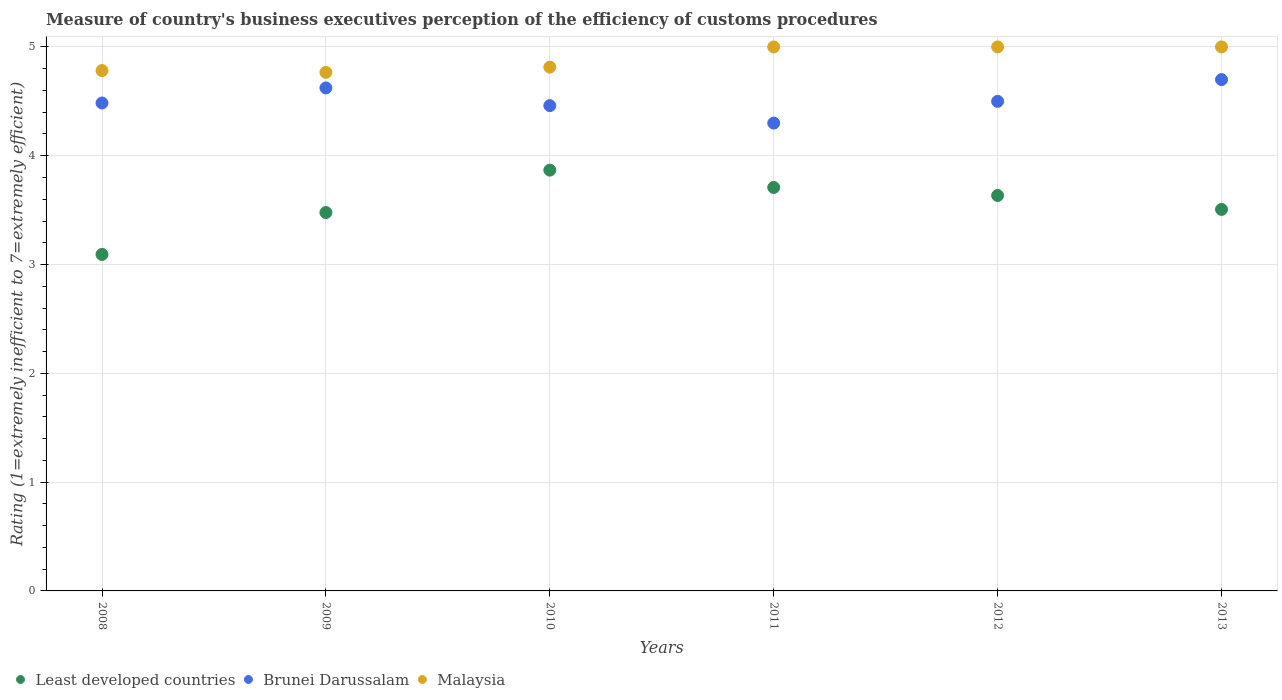What is the rating of the efficiency of customs procedure in Malaysia in 2012?
Your answer should be compact. 5. Across all years, what is the minimum rating of the efficiency of customs procedure in Least developed countries?
Keep it short and to the point. 3.09. What is the total rating of the efficiency of customs procedure in Least developed countries in the graph?
Provide a short and direct response. 21.29. What is the difference between the rating of the efficiency of customs procedure in Malaysia in 2008 and that in 2013?
Keep it short and to the point. -0.22. What is the difference between the rating of the efficiency of customs procedure in Least developed countries in 2013 and the rating of the efficiency of customs procedure in Brunei Darussalam in 2010?
Provide a succinct answer. -0.95. What is the average rating of the efficiency of customs procedure in Malaysia per year?
Your answer should be very brief. 4.89. In the year 2010, what is the difference between the rating of the efficiency of customs procedure in Brunei Darussalam and rating of the efficiency of customs procedure in Malaysia?
Your response must be concise. -0.35. What is the ratio of the rating of the efficiency of customs procedure in Malaysia in 2008 to that in 2010?
Provide a short and direct response. 0.99. What is the difference between the highest and the lowest rating of the efficiency of customs procedure in Malaysia?
Keep it short and to the point. 0.23. In how many years, is the rating of the efficiency of customs procedure in Least developed countries greater than the average rating of the efficiency of customs procedure in Least developed countries taken over all years?
Provide a short and direct response. 3. Is the sum of the rating of the efficiency of customs procedure in Least developed countries in 2009 and 2010 greater than the maximum rating of the efficiency of customs procedure in Malaysia across all years?
Provide a short and direct response. Yes. Is it the case that in every year, the sum of the rating of the efficiency of customs procedure in Brunei Darussalam and rating of the efficiency of customs procedure in Malaysia  is greater than the rating of the efficiency of customs procedure in Least developed countries?
Give a very brief answer. Yes. Is the rating of the efficiency of customs procedure in Malaysia strictly greater than the rating of the efficiency of customs procedure in Least developed countries over the years?
Your response must be concise. Yes. Is the rating of the efficiency of customs procedure in Least developed countries strictly less than the rating of the efficiency of customs procedure in Brunei Darussalam over the years?
Your answer should be compact. Yes. How many dotlines are there?
Keep it short and to the point. 3. Are the values on the major ticks of Y-axis written in scientific E-notation?
Ensure brevity in your answer.  No. Does the graph contain grids?
Give a very brief answer. Yes. What is the title of the graph?
Offer a terse response. Measure of country's business executives perception of the efficiency of customs procedures. Does "Spain" appear as one of the legend labels in the graph?
Ensure brevity in your answer.  No. What is the label or title of the X-axis?
Ensure brevity in your answer.  Years. What is the label or title of the Y-axis?
Your response must be concise. Rating (1=extremely inefficient to 7=extremely efficient). What is the Rating (1=extremely inefficient to 7=extremely efficient) of Least developed countries in 2008?
Keep it short and to the point. 3.09. What is the Rating (1=extremely inefficient to 7=extremely efficient) in Brunei Darussalam in 2008?
Your answer should be compact. 4.48. What is the Rating (1=extremely inefficient to 7=extremely efficient) of Malaysia in 2008?
Keep it short and to the point. 4.78. What is the Rating (1=extremely inefficient to 7=extremely efficient) in Least developed countries in 2009?
Provide a short and direct response. 3.48. What is the Rating (1=extremely inefficient to 7=extremely efficient) in Brunei Darussalam in 2009?
Your response must be concise. 4.62. What is the Rating (1=extremely inefficient to 7=extremely efficient) in Malaysia in 2009?
Keep it short and to the point. 4.77. What is the Rating (1=extremely inefficient to 7=extremely efficient) of Least developed countries in 2010?
Keep it short and to the point. 3.87. What is the Rating (1=extremely inefficient to 7=extremely efficient) in Brunei Darussalam in 2010?
Offer a very short reply. 4.46. What is the Rating (1=extremely inefficient to 7=extremely efficient) in Malaysia in 2010?
Give a very brief answer. 4.81. What is the Rating (1=extremely inefficient to 7=extremely efficient) in Least developed countries in 2011?
Give a very brief answer. 3.71. What is the Rating (1=extremely inefficient to 7=extremely efficient) of Malaysia in 2011?
Give a very brief answer. 5. What is the Rating (1=extremely inefficient to 7=extremely efficient) of Least developed countries in 2012?
Give a very brief answer. 3.63. What is the Rating (1=extremely inefficient to 7=extremely efficient) in Malaysia in 2012?
Make the answer very short. 5. What is the Rating (1=extremely inefficient to 7=extremely efficient) in Least developed countries in 2013?
Give a very brief answer. 3.51. Across all years, what is the maximum Rating (1=extremely inefficient to 7=extremely efficient) in Least developed countries?
Your answer should be very brief. 3.87. Across all years, what is the maximum Rating (1=extremely inefficient to 7=extremely efficient) in Malaysia?
Make the answer very short. 5. Across all years, what is the minimum Rating (1=extremely inefficient to 7=extremely efficient) of Least developed countries?
Ensure brevity in your answer.  3.09. Across all years, what is the minimum Rating (1=extremely inefficient to 7=extremely efficient) in Malaysia?
Offer a very short reply. 4.77. What is the total Rating (1=extremely inefficient to 7=extremely efficient) in Least developed countries in the graph?
Provide a short and direct response. 21.29. What is the total Rating (1=extremely inefficient to 7=extremely efficient) of Brunei Darussalam in the graph?
Offer a terse response. 27.07. What is the total Rating (1=extremely inefficient to 7=extremely efficient) of Malaysia in the graph?
Keep it short and to the point. 29.36. What is the difference between the Rating (1=extremely inefficient to 7=extremely efficient) of Least developed countries in 2008 and that in 2009?
Offer a terse response. -0.39. What is the difference between the Rating (1=extremely inefficient to 7=extremely efficient) in Brunei Darussalam in 2008 and that in 2009?
Provide a short and direct response. -0.14. What is the difference between the Rating (1=extremely inefficient to 7=extremely efficient) of Malaysia in 2008 and that in 2009?
Make the answer very short. 0.02. What is the difference between the Rating (1=extremely inefficient to 7=extremely efficient) of Least developed countries in 2008 and that in 2010?
Offer a terse response. -0.77. What is the difference between the Rating (1=extremely inefficient to 7=extremely efficient) of Brunei Darussalam in 2008 and that in 2010?
Offer a terse response. 0.02. What is the difference between the Rating (1=extremely inefficient to 7=extremely efficient) of Malaysia in 2008 and that in 2010?
Your answer should be very brief. -0.03. What is the difference between the Rating (1=extremely inefficient to 7=extremely efficient) of Least developed countries in 2008 and that in 2011?
Make the answer very short. -0.62. What is the difference between the Rating (1=extremely inefficient to 7=extremely efficient) of Brunei Darussalam in 2008 and that in 2011?
Give a very brief answer. 0.18. What is the difference between the Rating (1=extremely inefficient to 7=extremely efficient) of Malaysia in 2008 and that in 2011?
Offer a very short reply. -0.22. What is the difference between the Rating (1=extremely inefficient to 7=extremely efficient) of Least developed countries in 2008 and that in 2012?
Provide a succinct answer. -0.54. What is the difference between the Rating (1=extremely inefficient to 7=extremely efficient) in Brunei Darussalam in 2008 and that in 2012?
Ensure brevity in your answer.  -0.02. What is the difference between the Rating (1=extremely inefficient to 7=extremely efficient) of Malaysia in 2008 and that in 2012?
Your answer should be compact. -0.22. What is the difference between the Rating (1=extremely inefficient to 7=extremely efficient) of Least developed countries in 2008 and that in 2013?
Offer a very short reply. -0.41. What is the difference between the Rating (1=extremely inefficient to 7=extremely efficient) in Brunei Darussalam in 2008 and that in 2013?
Make the answer very short. -0.22. What is the difference between the Rating (1=extremely inefficient to 7=extremely efficient) in Malaysia in 2008 and that in 2013?
Your response must be concise. -0.22. What is the difference between the Rating (1=extremely inefficient to 7=extremely efficient) in Least developed countries in 2009 and that in 2010?
Keep it short and to the point. -0.39. What is the difference between the Rating (1=extremely inefficient to 7=extremely efficient) of Brunei Darussalam in 2009 and that in 2010?
Provide a succinct answer. 0.16. What is the difference between the Rating (1=extremely inefficient to 7=extremely efficient) in Malaysia in 2009 and that in 2010?
Your answer should be compact. -0.05. What is the difference between the Rating (1=extremely inefficient to 7=extremely efficient) in Least developed countries in 2009 and that in 2011?
Your answer should be very brief. -0.23. What is the difference between the Rating (1=extremely inefficient to 7=extremely efficient) in Brunei Darussalam in 2009 and that in 2011?
Give a very brief answer. 0.32. What is the difference between the Rating (1=extremely inefficient to 7=extremely efficient) in Malaysia in 2009 and that in 2011?
Make the answer very short. -0.23. What is the difference between the Rating (1=extremely inefficient to 7=extremely efficient) of Least developed countries in 2009 and that in 2012?
Make the answer very short. -0.16. What is the difference between the Rating (1=extremely inefficient to 7=extremely efficient) in Brunei Darussalam in 2009 and that in 2012?
Your answer should be very brief. 0.12. What is the difference between the Rating (1=extremely inefficient to 7=extremely efficient) of Malaysia in 2009 and that in 2012?
Provide a succinct answer. -0.23. What is the difference between the Rating (1=extremely inefficient to 7=extremely efficient) in Least developed countries in 2009 and that in 2013?
Ensure brevity in your answer.  -0.03. What is the difference between the Rating (1=extremely inefficient to 7=extremely efficient) of Brunei Darussalam in 2009 and that in 2013?
Provide a succinct answer. -0.08. What is the difference between the Rating (1=extremely inefficient to 7=extremely efficient) of Malaysia in 2009 and that in 2013?
Provide a succinct answer. -0.23. What is the difference between the Rating (1=extremely inefficient to 7=extremely efficient) of Least developed countries in 2010 and that in 2011?
Keep it short and to the point. 0.16. What is the difference between the Rating (1=extremely inefficient to 7=extremely efficient) in Brunei Darussalam in 2010 and that in 2011?
Provide a succinct answer. 0.16. What is the difference between the Rating (1=extremely inefficient to 7=extremely efficient) in Malaysia in 2010 and that in 2011?
Your answer should be very brief. -0.19. What is the difference between the Rating (1=extremely inefficient to 7=extremely efficient) of Least developed countries in 2010 and that in 2012?
Ensure brevity in your answer.  0.23. What is the difference between the Rating (1=extremely inefficient to 7=extremely efficient) of Brunei Darussalam in 2010 and that in 2012?
Your response must be concise. -0.04. What is the difference between the Rating (1=extremely inefficient to 7=extremely efficient) in Malaysia in 2010 and that in 2012?
Ensure brevity in your answer.  -0.19. What is the difference between the Rating (1=extremely inefficient to 7=extremely efficient) of Least developed countries in 2010 and that in 2013?
Offer a terse response. 0.36. What is the difference between the Rating (1=extremely inefficient to 7=extremely efficient) of Brunei Darussalam in 2010 and that in 2013?
Your answer should be very brief. -0.24. What is the difference between the Rating (1=extremely inefficient to 7=extremely efficient) of Malaysia in 2010 and that in 2013?
Ensure brevity in your answer.  -0.19. What is the difference between the Rating (1=extremely inefficient to 7=extremely efficient) in Least developed countries in 2011 and that in 2012?
Keep it short and to the point. 0.07. What is the difference between the Rating (1=extremely inefficient to 7=extremely efficient) of Malaysia in 2011 and that in 2012?
Your answer should be very brief. 0. What is the difference between the Rating (1=extremely inefficient to 7=extremely efficient) of Least developed countries in 2011 and that in 2013?
Offer a terse response. 0.2. What is the difference between the Rating (1=extremely inefficient to 7=extremely efficient) of Brunei Darussalam in 2011 and that in 2013?
Offer a very short reply. -0.4. What is the difference between the Rating (1=extremely inefficient to 7=extremely efficient) in Least developed countries in 2012 and that in 2013?
Make the answer very short. 0.13. What is the difference between the Rating (1=extremely inefficient to 7=extremely efficient) in Malaysia in 2012 and that in 2013?
Offer a very short reply. 0. What is the difference between the Rating (1=extremely inefficient to 7=extremely efficient) in Least developed countries in 2008 and the Rating (1=extremely inefficient to 7=extremely efficient) in Brunei Darussalam in 2009?
Offer a very short reply. -1.53. What is the difference between the Rating (1=extremely inefficient to 7=extremely efficient) of Least developed countries in 2008 and the Rating (1=extremely inefficient to 7=extremely efficient) of Malaysia in 2009?
Keep it short and to the point. -1.67. What is the difference between the Rating (1=extremely inefficient to 7=extremely efficient) in Brunei Darussalam in 2008 and the Rating (1=extremely inefficient to 7=extremely efficient) in Malaysia in 2009?
Offer a terse response. -0.28. What is the difference between the Rating (1=extremely inefficient to 7=extremely efficient) of Least developed countries in 2008 and the Rating (1=extremely inefficient to 7=extremely efficient) of Brunei Darussalam in 2010?
Ensure brevity in your answer.  -1.37. What is the difference between the Rating (1=extremely inefficient to 7=extremely efficient) in Least developed countries in 2008 and the Rating (1=extremely inefficient to 7=extremely efficient) in Malaysia in 2010?
Provide a succinct answer. -1.72. What is the difference between the Rating (1=extremely inefficient to 7=extremely efficient) of Brunei Darussalam in 2008 and the Rating (1=extremely inefficient to 7=extremely efficient) of Malaysia in 2010?
Provide a short and direct response. -0.33. What is the difference between the Rating (1=extremely inefficient to 7=extremely efficient) in Least developed countries in 2008 and the Rating (1=extremely inefficient to 7=extremely efficient) in Brunei Darussalam in 2011?
Keep it short and to the point. -1.21. What is the difference between the Rating (1=extremely inefficient to 7=extremely efficient) of Least developed countries in 2008 and the Rating (1=extremely inefficient to 7=extremely efficient) of Malaysia in 2011?
Offer a terse response. -1.91. What is the difference between the Rating (1=extremely inefficient to 7=extremely efficient) in Brunei Darussalam in 2008 and the Rating (1=extremely inefficient to 7=extremely efficient) in Malaysia in 2011?
Offer a terse response. -0.52. What is the difference between the Rating (1=extremely inefficient to 7=extremely efficient) of Least developed countries in 2008 and the Rating (1=extremely inefficient to 7=extremely efficient) of Brunei Darussalam in 2012?
Your answer should be very brief. -1.41. What is the difference between the Rating (1=extremely inefficient to 7=extremely efficient) in Least developed countries in 2008 and the Rating (1=extremely inefficient to 7=extremely efficient) in Malaysia in 2012?
Keep it short and to the point. -1.91. What is the difference between the Rating (1=extremely inefficient to 7=extremely efficient) in Brunei Darussalam in 2008 and the Rating (1=extremely inefficient to 7=extremely efficient) in Malaysia in 2012?
Your answer should be compact. -0.52. What is the difference between the Rating (1=extremely inefficient to 7=extremely efficient) in Least developed countries in 2008 and the Rating (1=extremely inefficient to 7=extremely efficient) in Brunei Darussalam in 2013?
Offer a very short reply. -1.61. What is the difference between the Rating (1=extremely inefficient to 7=extremely efficient) of Least developed countries in 2008 and the Rating (1=extremely inefficient to 7=extremely efficient) of Malaysia in 2013?
Your response must be concise. -1.91. What is the difference between the Rating (1=extremely inefficient to 7=extremely efficient) of Brunei Darussalam in 2008 and the Rating (1=extremely inefficient to 7=extremely efficient) of Malaysia in 2013?
Your answer should be compact. -0.52. What is the difference between the Rating (1=extremely inefficient to 7=extremely efficient) of Least developed countries in 2009 and the Rating (1=extremely inefficient to 7=extremely efficient) of Brunei Darussalam in 2010?
Your response must be concise. -0.98. What is the difference between the Rating (1=extremely inefficient to 7=extremely efficient) of Least developed countries in 2009 and the Rating (1=extremely inefficient to 7=extremely efficient) of Malaysia in 2010?
Your answer should be compact. -1.34. What is the difference between the Rating (1=extremely inefficient to 7=extremely efficient) in Brunei Darussalam in 2009 and the Rating (1=extremely inefficient to 7=extremely efficient) in Malaysia in 2010?
Provide a short and direct response. -0.19. What is the difference between the Rating (1=extremely inefficient to 7=extremely efficient) in Least developed countries in 2009 and the Rating (1=extremely inefficient to 7=extremely efficient) in Brunei Darussalam in 2011?
Ensure brevity in your answer.  -0.82. What is the difference between the Rating (1=extremely inefficient to 7=extremely efficient) of Least developed countries in 2009 and the Rating (1=extremely inefficient to 7=extremely efficient) of Malaysia in 2011?
Provide a succinct answer. -1.52. What is the difference between the Rating (1=extremely inefficient to 7=extremely efficient) of Brunei Darussalam in 2009 and the Rating (1=extremely inefficient to 7=extremely efficient) of Malaysia in 2011?
Give a very brief answer. -0.38. What is the difference between the Rating (1=extremely inefficient to 7=extremely efficient) of Least developed countries in 2009 and the Rating (1=extremely inefficient to 7=extremely efficient) of Brunei Darussalam in 2012?
Ensure brevity in your answer.  -1.02. What is the difference between the Rating (1=extremely inefficient to 7=extremely efficient) in Least developed countries in 2009 and the Rating (1=extremely inefficient to 7=extremely efficient) in Malaysia in 2012?
Keep it short and to the point. -1.52. What is the difference between the Rating (1=extremely inefficient to 7=extremely efficient) in Brunei Darussalam in 2009 and the Rating (1=extremely inefficient to 7=extremely efficient) in Malaysia in 2012?
Your answer should be compact. -0.38. What is the difference between the Rating (1=extremely inefficient to 7=extremely efficient) of Least developed countries in 2009 and the Rating (1=extremely inefficient to 7=extremely efficient) of Brunei Darussalam in 2013?
Offer a very short reply. -1.22. What is the difference between the Rating (1=extremely inefficient to 7=extremely efficient) of Least developed countries in 2009 and the Rating (1=extremely inefficient to 7=extremely efficient) of Malaysia in 2013?
Give a very brief answer. -1.52. What is the difference between the Rating (1=extremely inefficient to 7=extremely efficient) of Brunei Darussalam in 2009 and the Rating (1=extremely inefficient to 7=extremely efficient) of Malaysia in 2013?
Make the answer very short. -0.38. What is the difference between the Rating (1=extremely inefficient to 7=extremely efficient) in Least developed countries in 2010 and the Rating (1=extremely inefficient to 7=extremely efficient) in Brunei Darussalam in 2011?
Offer a terse response. -0.43. What is the difference between the Rating (1=extremely inefficient to 7=extremely efficient) of Least developed countries in 2010 and the Rating (1=extremely inefficient to 7=extremely efficient) of Malaysia in 2011?
Offer a very short reply. -1.13. What is the difference between the Rating (1=extremely inefficient to 7=extremely efficient) of Brunei Darussalam in 2010 and the Rating (1=extremely inefficient to 7=extremely efficient) of Malaysia in 2011?
Your response must be concise. -0.54. What is the difference between the Rating (1=extremely inefficient to 7=extremely efficient) in Least developed countries in 2010 and the Rating (1=extremely inefficient to 7=extremely efficient) in Brunei Darussalam in 2012?
Your answer should be compact. -0.63. What is the difference between the Rating (1=extremely inefficient to 7=extremely efficient) of Least developed countries in 2010 and the Rating (1=extremely inefficient to 7=extremely efficient) of Malaysia in 2012?
Give a very brief answer. -1.13. What is the difference between the Rating (1=extremely inefficient to 7=extremely efficient) in Brunei Darussalam in 2010 and the Rating (1=extremely inefficient to 7=extremely efficient) in Malaysia in 2012?
Your response must be concise. -0.54. What is the difference between the Rating (1=extremely inefficient to 7=extremely efficient) in Least developed countries in 2010 and the Rating (1=extremely inefficient to 7=extremely efficient) in Brunei Darussalam in 2013?
Provide a succinct answer. -0.83. What is the difference between the Rating (1=extremely inefficient to 7=extremely efficient) of Least developed countries in 2010 and the Rating (1=extremely inefficient to 7=extremely efficient) of Malaysia in 2013?
Make the answer very short. -1.13. What is the difference between the Rating (1=extremely inefficient to 7=extremely efficient) of Brunei Darussalam in 2010 and the Rating (1=extremely inefficient to 7=extremely efficient) of Malaysia in 2013?
Make the answer very short. -0.54. What is the difference between the Rating (1=extremely inefficient to 7=extremely efficient) in Least developed countries in 2011 and the Rating (1=extremely inefficient to 7=extremely efficient) in Brunei Darussalam in 2012?
Your response must be concise. -0.79. What is the difference between the Rating (1=extremely inefficient to 7=extremely efficient) of Least developed countries in 2011 and the Rating (1=extremely inefficient to 7=extremely efficient) of Malaysia in 2012?
Provide a succinct answer. -1.29. What is the difference between the Rating (1=extremely inefficient to 7=extremely efficient) in Brunei Darussalam in 2011 and the Rating (1=extremely inefficient to 7=extremely efficient) in Malaysia in 2012?
Keep it short and to the point. -0.7. What is the difference between the Rating (1=extremely inefficient to 7=extremely efficient) of Least developed countries in 2011 and the Rating (1=extremely inefficient to 7=extremely efficient) of Brunei Darussalam in 2013?
Your answer should be compact. -0.99. What is the difference between the Rating (1=extremely inefficient to 7=extremely efficient) of Least developed countries in 2011 and the Rating (1=extremely inefficient to 7=extremely efficient) of Malaysia in 2013?
Give a very brief answer. -1.29. What is the difference between the Rating (1=extremely inefficient to 7=extremely efficient) of Least developed countries in 2012 and the Rating (1=extremely inefficient to 7=extremely efficient) of Brunei Darussalam in 2013?
Keep it short and to the point. -1.07. What is the difference between the Rating (1=extremely inefficient to 7=extremely efficient) in Least developed countries in 2012 and the Rating (1=extremely inefficient to 7=extremely efficient) in Malaysia in 2013?
Provide a short and direct response. -1.37. What is the average Rating (1=extremely inefficient to 7=extremely efficient) in Least developed countries per year?
Make the answer very short. 3.55. What is the average Rating (1=extremely inefficient to 7=extremely efficient) in Brunei Darussalam per year?
Provide a short and direct response. 4.51. What is the average Rating (1=extremely inefficient to 7=extremely efficient) in Malaysia per year?
Give a very brief answer. 4.89. In the year 2008, what is the difference between the Rating (1=extremely inefficient to 7=extremely efficient) of Least developed countries and Rating (1=extremely inefficient to 7=extremely efficient) of Brunei Darussalam?
Offer a terse response. -1.39. In the year 2008, what is the difference between the Rating (1=extremely inefficient to 7=extremely efficient) of Least developed countries and Rating (1=extremely inefficient to 7=extremely efficient) of Malaysia?
Offer a terse response. -1.69. In the year 2008, what is the difference between the Rating (1=extremely inefficient to 7=extremely efficient) in Brunei Darussalam and Rating (1=extremely inefficient to 7=extremely efficient) in Malaysia?
Your answer should be very brief. -0.3. In the year 2009, what is the difference between the Rating (1=extremely inefficient to 7=extremely efficient) in Least developed countries and Rating (1=extremely inefficient to 7=extremely efficient) in Brunei Darussalam?
Offer a very short reply. -1.15. In the year 2009, what is the difference between the Rating (1=extremely inefficient to 7=extremely efficient) of Least developed countries and Rating (1=extremely inefficient to 7=extremely efficient) of Malaysia?
Provide a short and direct response. -1.29. In the year 2009, what is the difference between the Rating (1=extremely inefficient to 7=extremely efficient) in Brunei Darussalam and Rating (1=extremely inefficient to 7=extremely efficient) in Malaysia?
Offer a terse response. -0.14. In the year 2010, what is the difference between the Rating (1=extremely inefficient to 7=extremely efficient) in Least developed countries and Rating (1=extremely inefficient to 7=extremely efficient) in Brunei Darussalam?
Your answer should be compact. -0.59. In the year 2010, what is the difference between the Rating (1=extremely inefficient to 7=extremely efficient) in Least developed countries and Rating (1=extremely inefficient to 7=extremely efficient) in Malaysia?
Your answer should be very brief. -0.95. In the year 2010, what is the difference between the Rating (1=extremely inefficient to 7=extremely efficient) of Brunei Darussalam and Rating (1=extremely inefficient to 7=extremely efficient) of Malaysia?
Make the answer very short. -0.35. In the year 2011, what is the difference between the Rating (1=extremely inefficient to 7=extremely efficient) of Least developed countries and Rating (1=extremely inefficient to 7=extremely efficient) of Brunei Darussalam?
Provide a short and direct response. -0.59. In the year 2011, what is the difference between the Rating (1=extremely inefficient to 7=extremely efficient) in Least developed countries and Rating (1=extremely inefficient to 7=extremely efficient) in Malaysia?
Your answer should be very brief. -1.29. In the year 2011, what is the difference between the Rating (1=extremely inefficient to 7=extremely efficient) in Brunei Darussalam and Rating (1=extremely inefficient to 7=extremely efficient) in Malaysia?
Provide a succinct answer. -0.7. In the year 2012, what is the difference between the Rating (1=extremely inefficient to 7=extremely efficient) of Least developed countries and Rating (1=extremely inefficient to 7=extremely efficient) of Brunei Darussalam?
Your answer should be compact. -0.87. In the year 2012, what is the difference between the Rating (1=extremely inefficient to 7=extremely efficient) of Least developed countries and Rating (1=extremely inefficient to 7=extremely efficient) of Malaysia?
Your answer should be compact. -1.37. In the year 2012, what is the difference between the Rating (1=extremely inefficient to 7=extremely efficient) of Brunei Darussalam and Rating (1=extremely inefficient to 7=extremely efficient) of Malaysia?
Provide a succinct answer. -0.5. In the year 2013, what is the difference between the Rating (1=extremely inefficient to 7=extremely efficient) in Least developed countries and Rating (1=extremely inefficient to 7=extremely efficient) in Brunei Darussalam?
Offer a terse response. -1.19. In the year 2013, what is the difference between the Rating (1=extremely inefficient to 7=extremely efficient) of Least developed countries and Rating (1=extremely inefficient to 7=extremely efficient) of Malaysia?
Your answer should be very brief. -1.49. In the year 2013, what is the difference between the Rating (1=extremely inefficient to 7=extremely efficient) of Brunei Darussalam and Rating (1=extremely inefficient to 7=extremely efficient) of Malaysia?
Provide a short and direct response. -0.3. What is the ratio of the Rating (1=extremely inefficient to 7=extremely efficient) of Least developed countries in 2008 to that in 2009?
Make the answer very short. 0.89. What is the ratio of the Rating (1=extremely inefficient to 7=extremely efficient) in Brunei Darussalam in 2008 to that in 2009?
Your response must be concise. 0.97. What is the ratio of the Rating (1=extremely inefficient to 7=extremely efficient) in Least developed countries in 2008 to that in 2010?
Make the answer very short. 0.8. What is the ratio of the Rating (1=extremely inefficient to 7=extremely efficient) in Brunei Darussalam in 2008 to that in 2010?
Your answer should be very brief. 1.01. What is the ratio of the Rating (1=extremely inefficient to 7=extremely efficient) of Malaysia in 2008 to that in 2010?
Ensure brevity in your answer.  0.99. What is the ratio of the Rating (1=extremely inefficient to 7=extremely efficient) of Least developed countries in 2008 to that in 2011?
Ensure brevity in your answer.  0.83. What is the ratio of the Rating (1=extremely inefficient to 7=extremely efficient) in Brunei Darussalam in 2008 to that in 2011?
Your response must be concise. 1.04. What is the ratio of the Rating (1=extremely inefficient to 7=extremely efficient) in Malaysia in 2008 to that in 2011?
Ensure brevity in your answer.  0.96. What is the ratio of the Rating (1=extremely inefficient to 7=extremely efficient) of Least developed countries in 2008 to that in 2012?
Provide a succinct answer. 0.85. What is the ratio of the Rating (1=extremely inefficient to 7=extremely efficient) of Malaysia in 2008 to that in 2012?
Offer a very short reply. 0.96. What is the ratio of the Rating (1=extremely inefficient to 7=extremely efficient) of Least developed countries in 2008 to that in 2013?
Ensure brevity in your answer.  0.88. What is the ratio of the Rating (1=extremely inefficient to 7=extremely efficient) in Brunei Darussalam in 2008 to that in 2013?
Make the answer very short. 0.95. What is the ratio of the Rating (1=extremely inefficient to 7=extremely efficient) in Malaysia in 2008 to that in 2013?
Provide a succinct answer. 0.96. What is the ratio of the Rating (1=extremely inefficient to 7=extremely efficient) in Least developed countries in 2009 to that in 2010?
Give a very brief answer. 0.9. What is the ratio of the Rating (1=extremely inefficient to 7=extremely efficient) in Brunei Darussalam in 2009 to that in 2010?
Your response must be concise. 1.04. What is the ratio of the Rating (1=extremely inefficient to 7=extremely efficient) in Least developed countries in 2009 to that in 2011?
Keep it short and to the point. 0.94. What is the ratio of the Rating (1=extremely inefficient to 7=extremely efficient) of Brunei Darussalam in 2009 to that in 2011?
Your answer should be compact. 1.08. What is the ratio of the Rating (1=extremely inefficient to 7=extremely efficient) of Malaysia in 2009 to that in 2011?
Give a very brief answer. 0.95. What is the ratio of the Rating (1=extremely inefficient to 7=extremely efficient) in Brunei Darussalam in 2009 to that in 2012?
Your answer should be compact. 1.03. What is the ratio of the Rating (1=extremely inefficient to 7=extremely efficient) in Malaysia in 2009 to that in 2012?
Your response must be concise. 0.95. What is the ratio of the Rating (1=extremely inefficient to 7=extremely efficient) in Least developed countries in 2009 to that in 2013?
Ensure brevity in your answer.  0.99. What is the ratio of the Rating (1=extremely inefficient to 7=extremely efficient) in Brunei Darussalam in 2009 to that in 2013?
Offer a terse response. 0.98. What is the ratio of the Rating (1=extremely inefficient to 7=extremely efficient) of Malaysia in 2009 to that in 2013?
Your answer should be compact. 0.95. What is the ratio of the Rating (1=extremely inefficient to 7=extremely efficient) in Least developed countries in 2010 to that in 2011?
Your response must be concise. 1.04. What is the ratio of the Rating (1=extremely inefficient to 7=extremely efficient) in Brunei Darussalam in 2010 to that in 2011?
Provide a short and direct response. 1.04. What is the ratio of the Rating (1=extremely inefficient to 7=extremely efficient) of Malaysia in 2010 to that in 2011?
Your response must be concise. 0.96. What is the ratio of the Rating (1=extremely inefficient to 7=extremely efficient) in Least developed countries in 2010 to that in 2012?
Keep it short and to the point. 1.06. What is the ratio of the Rating (1=extremely inefficient to 7=extremely efficient) of Brunei Darussalam in 2010 to that in 2012?
Your answer should be compact. 0.99. What is the ratio of the Rating (1=extremely inefficient to 7=extremely efficient) in Malaysia in 2010 to that in 2012?
Your answer should be very brief. 0.96. What is the ratio of the Rating (1=extremely inefficient to 7=extremely efficient) in Least developed countries in 2010 to that in 2013?
Offer a terse response. 1.1. What is the ratio of the Rating (1=extremely inefficient to 7=extremely efficient) in Brunei Darussalam in 2010 to that in 2013?
Make the answer very short. 0.95. What is the ratio of the Rating (1=extremely inefficient to 7=extremely efficient) of Malaysia in 2010 to that in 2013?
Your answer should be compact. 0.96. What is the ratio of the Rating (1=extremely inefficient to 7=extremely efficient) of Least developed countries in 2011 to that in 2012?
Offer a very short reply. 1.02. What is the ratio of the Rating (1=extremely inefficient to 7=extremely efficient) of Brunei Darussalam in 2011 to that in 2012?
Ensure brevity in your answer.  0.96. What is the ratio of the Rating (1=extremely inefficient to 7=extremely efficient) in Malaysia in 2011 to that in 2012?
Provide a short and direct response. 1. What is the ratio of the Rating (1=extremely inefficient to 7=extremely efficient) in Least developed countries in 2011 to that in 2013?
Provide a succinct answer. 1.06. What is the ratio of the Rating (1=extremely inefficient to 7=extremely efficient) of Brunei Darussalam in 2011 to that in 2013?
Make the answer very short. 0.91. What is the ratio of the Rating (1=extremely inefficient to 7=extremely efficient) in Malaysia in 2011 to that in 2013?
Your answer should be compact. 1. What is the ratio of the Rating (1=extremely inefficient to 7=extremely efficient) of Least developed countries in 2012 to that in 2013?
Your response must be concise. 1.04. What is the ratio of the Rating (1=extremely inefficient to 7=extremely efficient) of Brunei Darussalam in 2012 to that in 2013?
Ensure brevity in your answer.  0.96. What is the ratio of the Rating (1=extremely inefficient to 7=extremely efficient) of Malaysia in 2012 to that in 2013?
Offer a very short reply. 1. What is the difference between the highest and the second highest Rating (1=extremely inefficient to 7=extremely efficient) in Least developed countries?
Offer a terse response. 0.16. What is the difference between the highest and the second highest Rating (1=extremely inefficient to 7=extremely efficient) in Brunei Darussalam?
Keep it short and to the point. 0.08. What is the difference between the highest and the second highest Rating (1=extremely inefficient to 7=extremely efficient) of Malaysia?
Provide a short and direct response. 0. What is the difference between the highest and the lowest Rating (1=extremely inefficient to 7=extremely efficient) of Least developed countries?
Offer a very short reply. 0.77. What is the difference between the highest and the lowest Rating (1=extremely inefficient to 7=extremely efficient) in Brunei Darussalam?
Your answer should be very brief. 0.4. What is the difference between the highest and the lowest Rating (1=extremely inefficient to 7=extremely efficient) in Malaysia?
Your answer should be very brief. 0.23. 